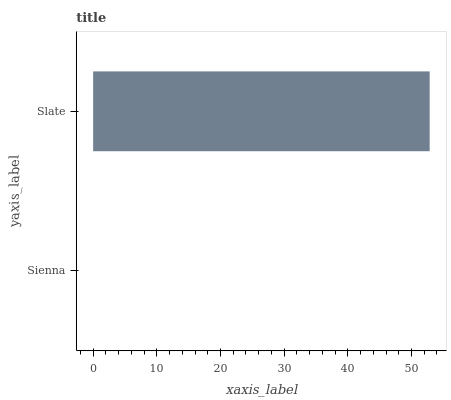Is Sienna the minimum?
Answer yes or no. Yes. Is Slate the maximum?
Answer yes or no. Yes. Is Slate the minimum?
Answer yes or no. No. Is Slate greater than Sienna?
Answer yes or no. Yes. Is Sienna less than Slate?
Answer yes or no. Yes. Is Sienna greater than Slate?
Answer yes or no. No. Is Slate less than Sienna?
Answer yes or no. No. Is Slate the high median?
Answer yes or no. Yes. Is Sienna the low median?
Answer yes or no. Yes. Is Sienna the high median?
Answer yes or no. No. Is Slate the low median?
Answer yes or no. No. 